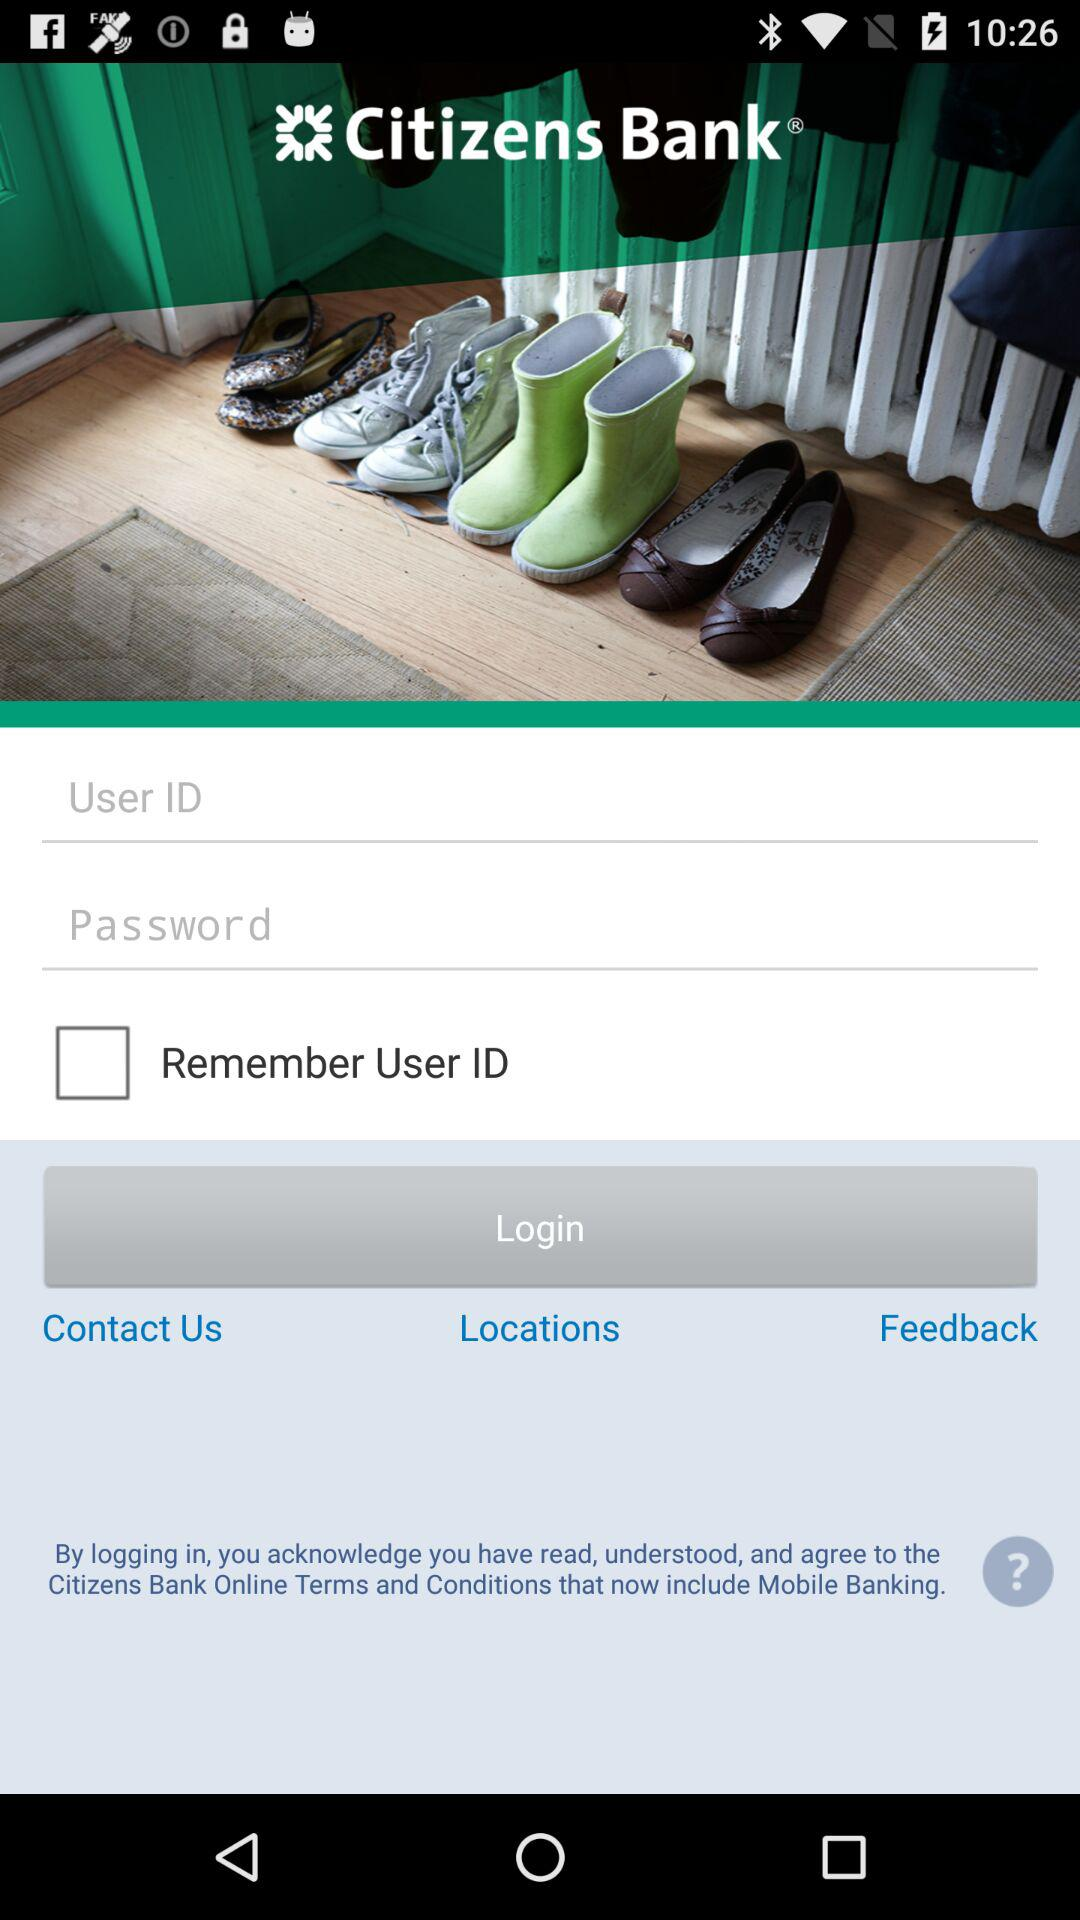How many text inputs are there for user credentials?
Answer the question using a single word or phrase. 2 